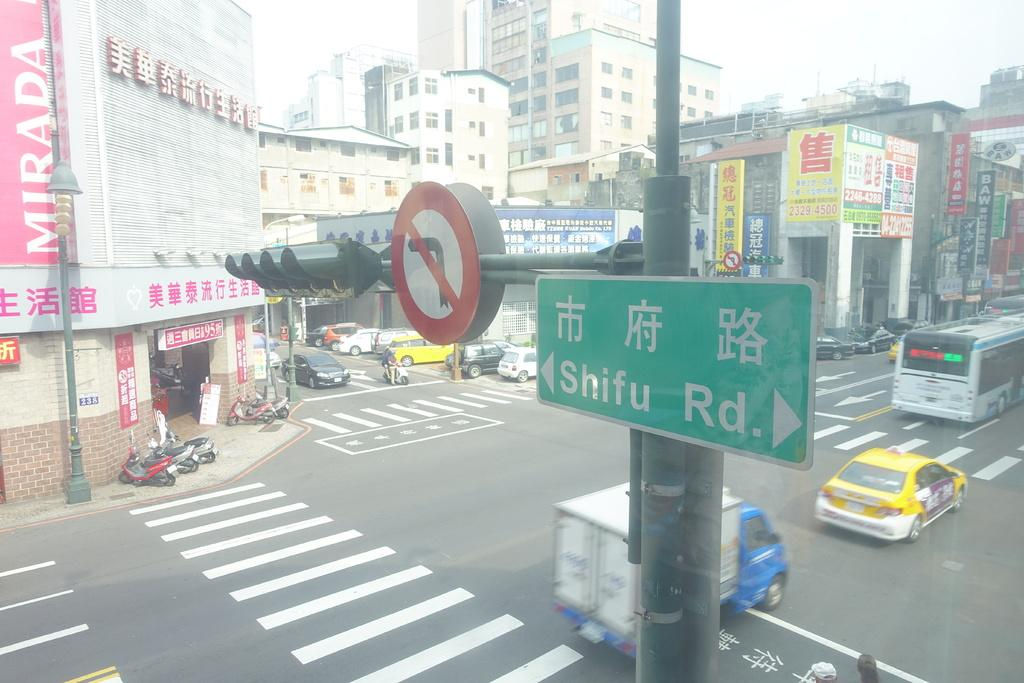<image>
Create a compact narrative representing the image presented. The intersection of Shifu Road in an Asian city. 